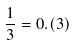Convert formula to latex. <formula><loc_0><loc_0><loc_500><loc_500>\frac { 1 } { 3 } = 0 . ( 3 )</formula> 